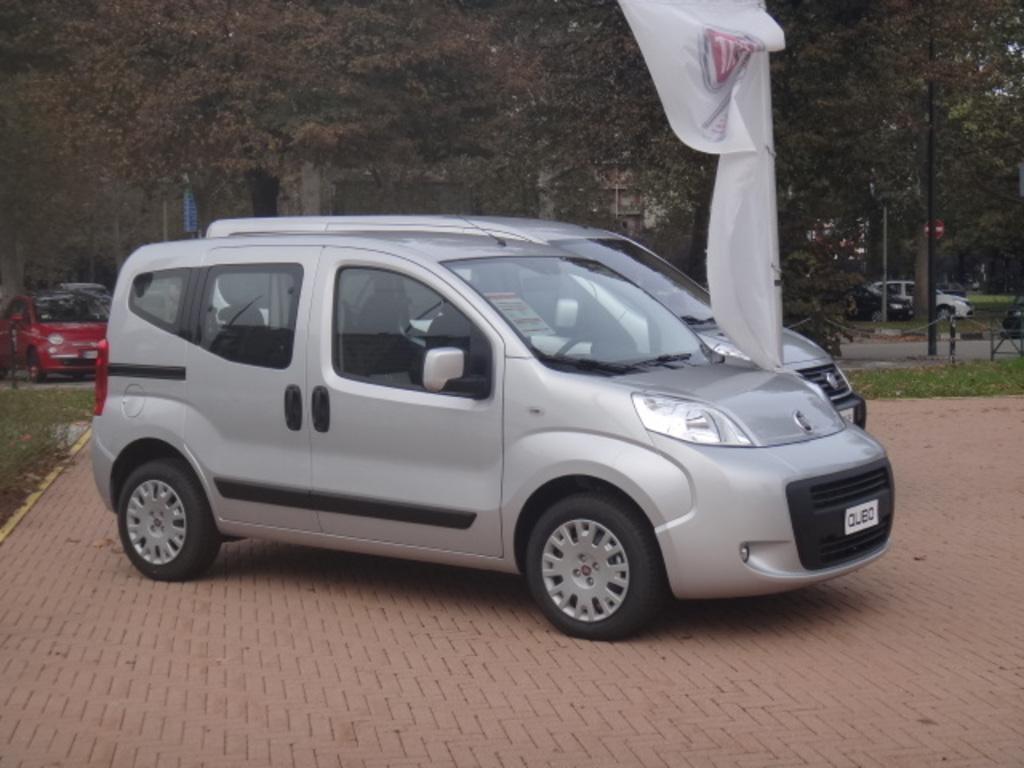Describe this image in one or two sentences. In this picture, we see two cars parked and we even see a flag in white color. Behind that, we see cars moving on the road. There are trees and buildings in the background. 